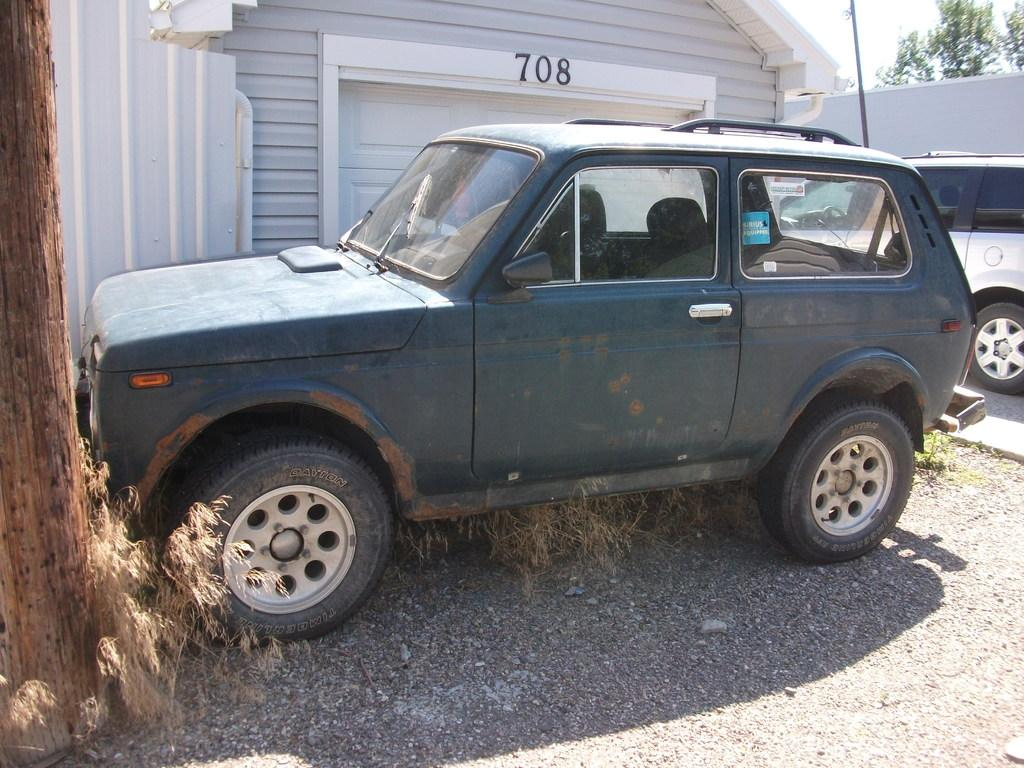<image>
Relay a brief, clear account of the picture shown. A black Jeep is parked in front of a garage that says 708. 